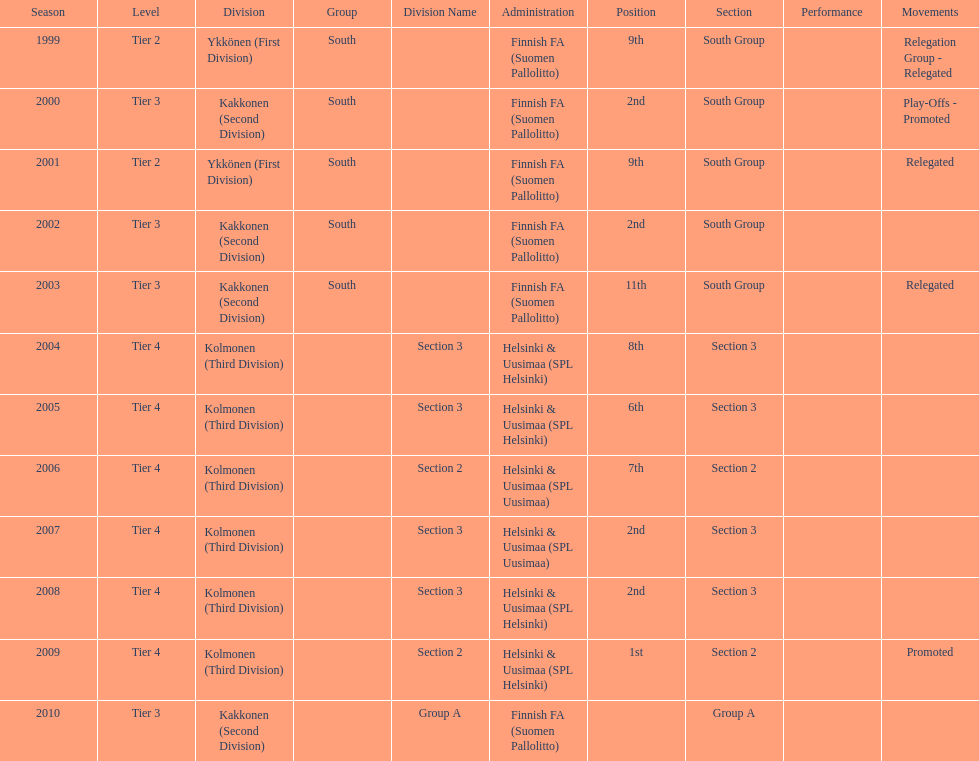How many consecutive times did they play in tier 4? 6. 